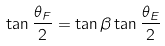<formula> <loc_0><loc_0><loc_500><loc_500>\tan { \frac { \theta _ { F } } { 2 } } = \tan { \beta } \tan { \frac { \theta _ { E } } { 2 } }</formula> 